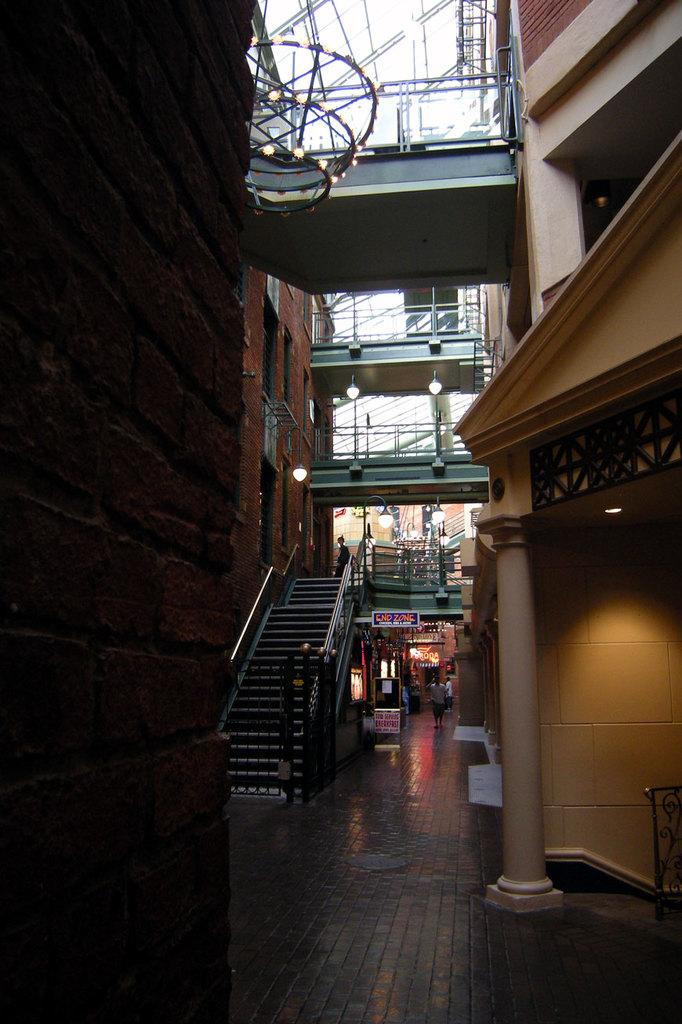What type of structures can be seen in the image? There are buildings in the image. What can be seen illuminating the scene in the image? There are lights in the image. Are there any architectural features that allow for vertical movement in the image? Yes, there are stairs in the image. Are there any human subjects present in the image? Yes, there are people in the image. What type of openings can be seen in the buildings in the image? There are windows in the image. What type of signage or information is present in the image? There are boards with text in the image. What type of barrier or divider can be seen in the image? There is a wall in the image. What type of cake is being served at the comfort station in the image? There is no cake or comfort station present in the image. How many rings are visible on the fingers of the people in the image? There is no mention of rings or fingers in the image. 